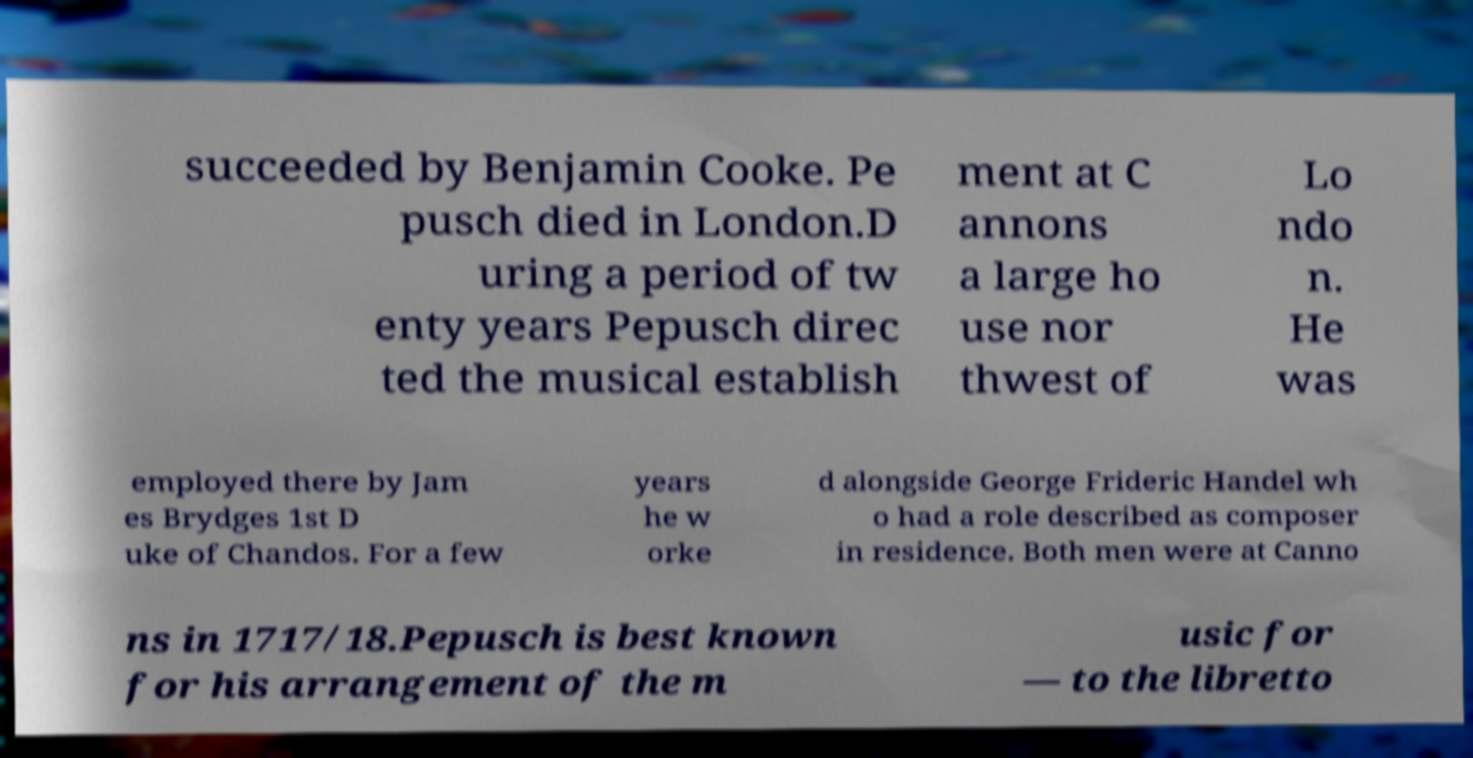There's text embedded in this image that I need extracted. Can you transcribe it verbatim? succeeded by Benjamin Cooke. Pe pusch died in London.D uring a period of tw enty years Pepusch direc ted the musical establish ment at C annons a large ho use nor thwest of Lo ndo n. He was employed there by Jam es Brydges 1st D uke of Chandos. For a few years he w orke d alongside George Frideric Handel wh o had a role described as composer in residence. Both men were at Canno ns in 1717/18.Pepusch is best known for his arrangement of the m usic for — to the libretto 